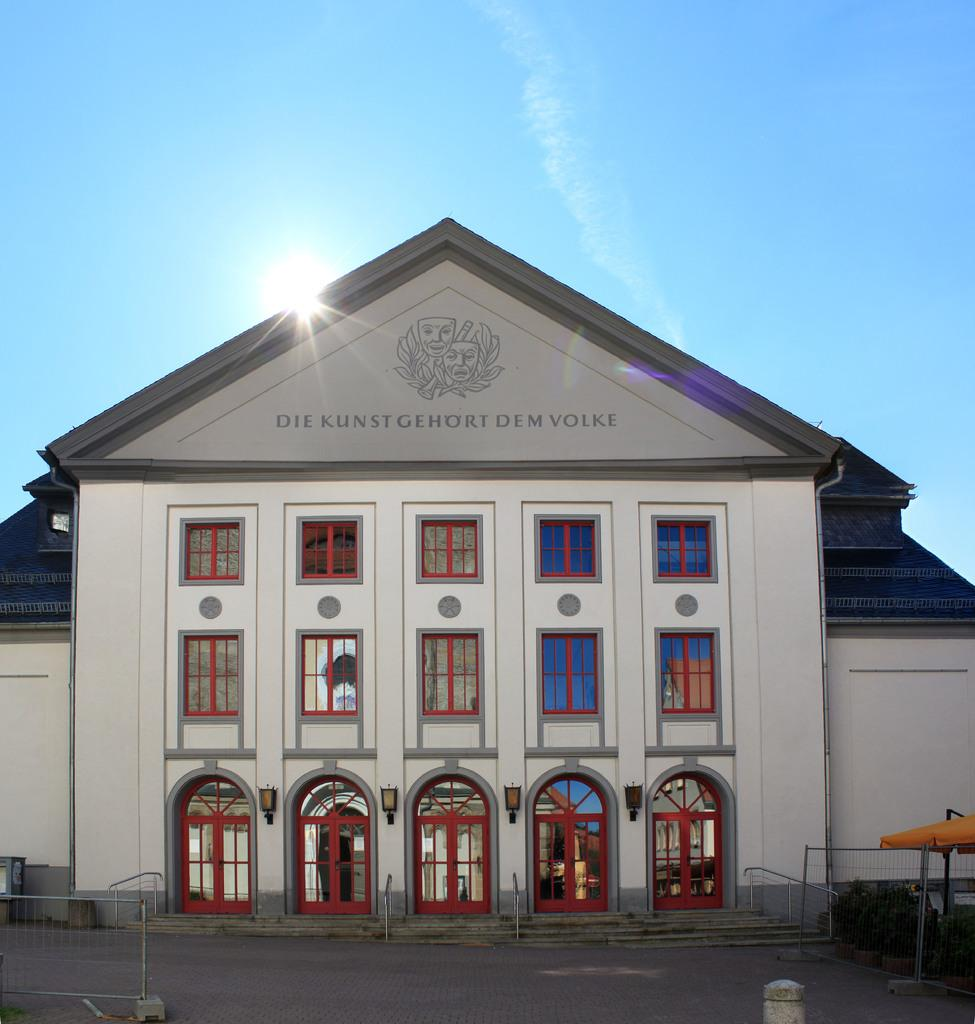Where was the image taken? The image was taken outside. What is the main subject in the middle of the image? There is a building in the middle of the image. What features can be seen on the building's exterior? The building has doors and windows. What is visible at the top of the image? The sky is visible at the top of the image. What type of trousers can be seen hanging from the building's windows in the image? There are no trousers visible in the image, and they are not hanging from the building's windows. What color is the curtain in the building's window in the image? There is no curtain visible in the image, as the windows are not covered. 